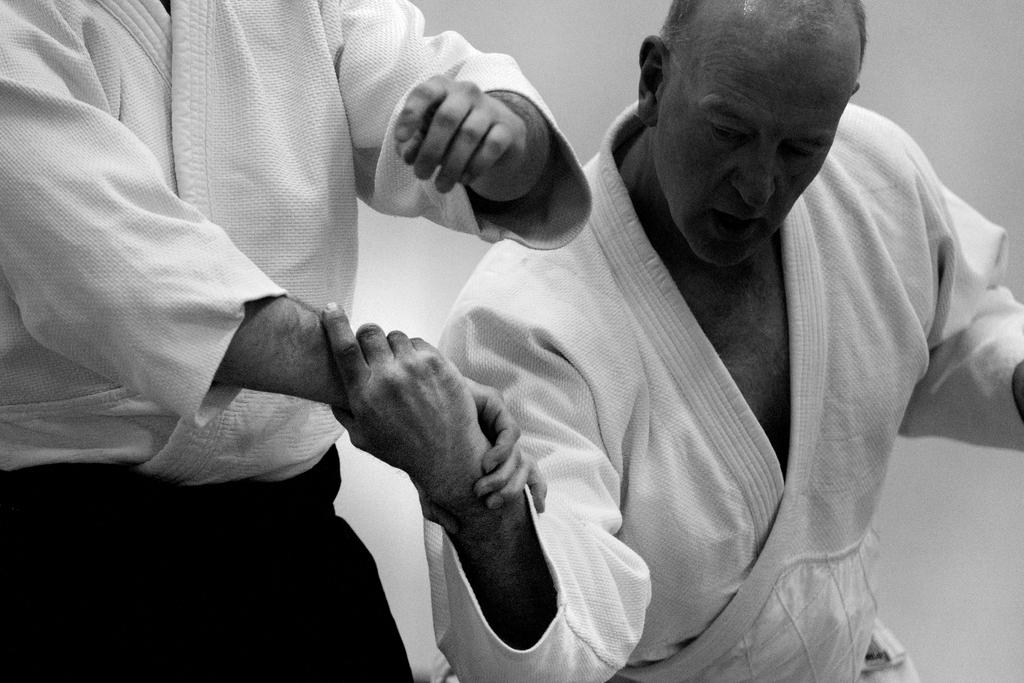How many people are in the image? There are two people in the image. What colors are the dresses of the people in the image? One person is wearing a white dress, and the other person is wearing a black dress. Can you describe the color scheme of the image? The image is in black and white. What type of loaf is being carried by the passenger in the image? There is no passenger or loaf present in the image. What part of the human body is depicted in the image? The image does not depict any human body parts; it features two people wearing dresses. 